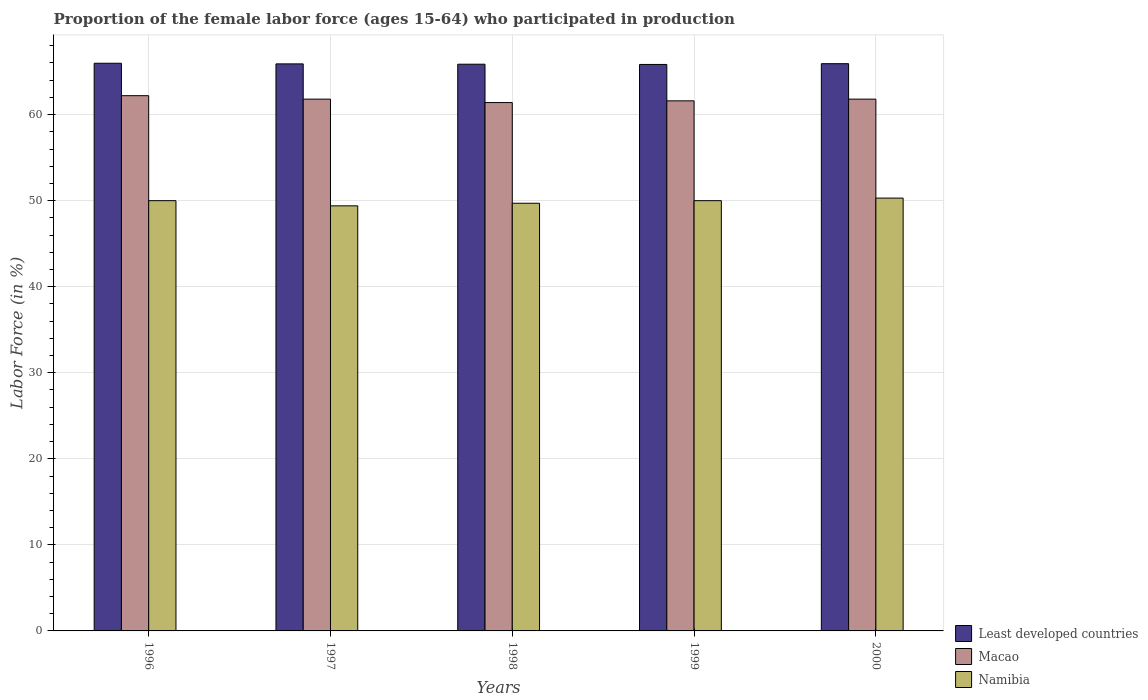Are the number of bars on each tick of the X-axis equal?
Your answer should be very brief. Yes. How many bars are there on the 4th tick from the right?
Make the answer very short. 3. What is the proportion of the female labor force who participated in production in Macao in 2000?
Keep it short and to the point. 61.8. Across all years, what is the maximum proportion of the female labor force who participated in production in Macao?
Provide a short and direct response. 62.2. Across all years, what is the minimum proportion of the female labor force who participated in production in Least developed countries?
Make the answer very short. 65.83. In which year was the proportion of the female labor force who participated in production in Macao maximum?
Offer a terse response. 1996. What is the total proportion of the female labor force who participated in production in Namibia in the graph?
Ensure brevity in your answer.  249.4. What is the difference between the proportion of the female labor force who participated in production in Namibia in 1996 and that in 1998?
Provide a short and direct response. 0.3. What is the difference between the proportion of the female labor force who participated in production in Least developed countries in 1997 and the proportion of the female labor force who participated in production in Macao in 1996?
Your answer should be compact. 3.7. What is the average proportion of the female labor force who participated in production in Macao per year?
Ensure brevity in your answer.  61.76. What is the ratio of the proportion of the female labor force who participated in production in Namibia in 1996 to that in 1999?
Provide a short and direct response. 1. What is the difference between the highest and the second highest proportion of the female labor force who participated in production in Least developed countries?
Provide a succinct answer. 0.05. What is the difference between the highest and the lowest proportion of the female labor force who participated in production in Namibia?
Your answer should be very brief. 0.9. In how many years, is the proportion of the female labor force who participated in production in Namibia greater than the average proportion of the female labor force who participated in production in Namibia taken over all years?
Provide a short and direct response. 3. What does the 3rd bar from the left in 1996 represents?
Offer a terse response. Namibia. What does the 2nd bar from the right in 2000 represents?
Provide a succinct answer. Macao. How many bars are there?
Provide a short and direct response. 15. Are the values on the major ticks of Y-axis written in scientific E-notation?
Ensure brevity in your answer.  No. Does the graph contain any zero values?
Offer a very short reply. No. How are the legend labels stacked?
Your answer should be compact. Vertical. What is the title of the graph?
Provide a succinct answer. Proportion of the female labor force (ages 15-64) who participated in production. Does "Montenegro" appear as one of the legend labels in the graph?
Give a very brief answer. No. What is the label or title of the Y-axis?
Make the answer very short. Labor Force (in %). What is the Labor Force (in %) in Least developed countries in 1996?
Ensure brevity in your answer.  65.97. What is the Labor Force (in %) in Macao in 1996?
Ensure brevity in your answer.  62.2. What is the Labor Force (in %) of Namibia in 1996?
Make the answer very short. 50. What is the Labor Force (in %) of Least developed countries in 1997?
Offer a very short reply. 65.9. What is the Labor Force (in %) in Macao in 1997?
Your answer should be compact. 61.8. What is the Labor Force (in %) in Namibia in 1997?
Ensure brevity in your answer.  49.4. What is the Labor Force (in %) in Least developed countries in 1998?
Give a very brief answer. 65.86. What is the Labor Force (in %) of Macao in 1998?
Ensure brevity in your answer.  61.4. What is the Labor Force (in %) of Namibia in 1998?
Ensure brevity in your answer.  49.7. What is the Labor Force (in %) in Least developed countries in 1999?
Your response must be concise. 65.83. What is the Labor Force (in %) of Macao in 1999?
Offer a very short reply. 61.6. What is the Labor Force (in %) in Least developed countries in 2000?
Offer a very short reply. 65.92. What is the Labor Force (in %) in Macao in 2000?
Make the answer very short. 61.8. What is the Labor Force (in %) in Namibia in 2000?
Give a very brief answer. 50.3. Across all years, what is the maximum Labor Force (in %) in Least developed countries?
Your response must be concise. 65.97. Across all years, what is the maximum Labor Force (in %) in Macao?
Offer a terse response. 62.2. Across all years, what is the maximum Labor Force (in %) of Namibia?
Your response must be concise. 50.3. Across all years, what is the minimum Labor Force (in %) of Least developed countries?
Offer a terse response. 65.83. Across all years, what is the minimum Labor Force (in %) in Macao?
Your response must be concise. 61.4. Across all years, what is the minimum Labor Force (in %) in Namibia?
Your answer should be very brief. 49.4. What is the total Labor Force (in %) in Least developed countries in the graph?
Ensure brevity in your answer.  329.47. What is the total Labor Force (in %) of Macao in the graph?
Your answer should be compact. 308.8. What is the total Labor Force (in %) in Namibia in the graph?
Keep it short and to the point. 249.4. What is the difference between the Labor Force (in %) in Least developed countries in 1996 and that in 1997?
Offer a terse response. 0.07. What is the difference between the Labor Force (in %) in Namibia in 1996 and that in 1997?
Your answer should be compact. 0.6. What is the difference between the Labor Force (in %) in Least developed countries in 1996 and that in 1998?
Your answer should be compact. 0.11. What is the difference between the Labor Force (in %) of Macao in 1996 and that in 1998?
Keep it short and to the point. 0.8. What is the difference between the Labor Force (in %) in Least developed countries in 1996 and that in 1999?
Make the answer very short. 0.14. What is the difference between the Labor Force (in %) of Namibia in 1996 and that in 1999?
Your response must be concise. 0. What is the difference between the Labor Force (in %) of Least developed countries in 1996 and that in 2000?
Make the answer very short. 0.05. What is the difference between the Labor Force (in %) of Namibia in 1996 and that in 2000?
Your answer should be compact. -0.3. What is the difference between the Labor Force (in %) in Least developed countries in 1997 and that in 1998?
Your answer should be compact. 0.04. What is the difference between the Labor Force (in %) of Least developed countries in 1997 and that in 1999?
Your answer should be very brief. 0.06. What is the difference between the Labor Force (in %) in Least developed countries in 1997 and that in 2000?
Offer a terse response. -0.02. What is the difference between the Labor Force (in %) in Least developed countries in 1998 and that in 1999?
Offer a very short reply. 0.03. What is the difference between the Labor Force (in %) of Namibia in 1998 and that in 1999?
Your answer should be compact. -0.3. What is the difference between the Labor Force (in %) in Least developed countries in 1998 and that in 2000?
Your answer should be very brief. -0.06. What is the difference between the Labor Force (in %) of Macao in 1998 and that in 2000?
Your response must be concise. -0.4. What is the difference between the Labor Force (in %) of Least developed countries in 1999 and that in 2000?
Ensure brevity in your answer.  -0.09. What is the difference between the Labor Force (in %) in Macao in 1999 and that in 2000?
Your answer should be very brief. -0.2. What is the difference between the Labor Force (in %) in Namibia in 1999 and that in 2000?
Provide a succinct answer. -0.3. What is the difference between the Labor Force (in %) of Least developed countries in 1996 and the Labor Force (in %) of Macao in 1997?
Your answer should be compact. 4.17. What is the difference between the Labor Force (in %) of Least developed countries in 1996 and the Labor Force (in %) of Namibia in 1997?
Your answer should be very brief. 16.57. What is the difference between the Labor Force (in %) in Macao in 1996 and the Labor Force (in %) in Namibia in 1997?
Ensure brevity in your answer.  12.8. What is the difference between the Labor Force (in %) in Least developed countries in 1996 and the Labor Force (in %) in Macao in 1998?
Ensure brevity in your answer.  4.57. What is the difference between the Labor Force (in %) of Least developed countries in 1996 and the Labor Force (in %) of Namibia in 1998?
Offer a very short reply. 16.27. What is the difference between the Labor Force (in %) in Macao in 1996 and the Labor Force (in %) in Namibia in 1998?
Keep it short and to the point. 12.5. What is the difference between the Labor Force (in %) in Least developed countries in 1996 and the Labor Force (in %) in Macao in 1999?
Offer a terse response. 4.37. What is the difference between the Labor Force (in %) of Least developed countries in 1996 and the Labor Force (in %) of Namibia in 1999?
Ensure brevity in your answer.  15.97. What is the difference between the Labor Force (in %) of Macao in 1996 and the Labor Force (in %) of Namibia in 1999?
Your response must be concise. 12.2. What is the difference between the Labor Force (in %) of Least developed countries in 1996 and the Labor Force (in %) of Macao in 2000?
Your answer should be compact. 4.17. What is the difference between the Labor Force (in %) in Least developed countries in 1996 and the Labor Force (in %) in Namibia in 2000?
Your response must be concise. 15.67. What is the difference between the Labor Force (in %) of Macao in 1996 and the Labor Force (in %) of Namibia in 2000?
Provide a succinct answer. 11.9. What is the difference between the Labor Force (in %) of Least developed countries in 1997 and the Labor Force (in %) of Macao in 1998?
Ensure brevity in your answer.  4.5. What is the difference between the Labor Force (in %) in Least developed countries in 1997 and the Labor Force (in %) in Namibia in 1998?
Provide a short and direct response. 16.2. What is the difference between the Labor Force (in %) of Macao in 1997 and the Labor Force (in %) of Namibia in 1998?
Provide a short and direct response. 12.1. What is the difference between the Labor Force (in %) in Least developed countries in 1997 and the Labor Force (in %) in Macao in 1999?
Ensure brevity in your answer.  4.3. What is the difference between the Labor Force (in %) in Least developed countries in 1997 and the Labor Force (in %) in Namibia in 1999?
Provide a succinct answer. 15.9. What is the difference between the Labor Force (in %) in Least developed countries in 1997 and the Labor Force (in %) in Macao in 2000?
Give a very brief answer. 4.1. What is the difference between the Labor Force (in %) of Least developed countries in 1997 and the Labor Force (in %) of Namibia in 2000?
Your answer should be very brief. 15.6. What is the difference between the Labor Force (in %) in Macao in 1997 and the Labor Force (in %) in Namibia in 2000?
Your response must be concise. 11.5. What is the difference between the Labor Force (in %) in Least developed countries in 1998 and the Labor Force (in %) in Macao in 1999?
Your response must be concise. 4.26. What is the difference between the Labor Force (in %) of Least developed countries in 1998 and the Labor Force (in %) of Namibia in 1999?
Keep it short and to the point. 15.86. What is the difference between the Labor Force (in %) in Macao in 1998 and the Labor Force (in %) in Namibia in 1999?
Your answer should be very brief. 11.4. What is the difference between the Labor Force (in %) of Least developed countries in 1998 and the Labor Force (in %) of Macao in 2000?
Offer a very short reply. 4.06. What is the difference between the Labor Force (in %) of Least developed countries in 1998 and the Labor Force (in %) of Namibia in 2000?
Your answer should be very brief. 15.56. What is the difference between the Labor Force (in %) of Macao in 1998 and the Labor Force (in %) of Namibia in 2000?
Provide a short and direct response. 11.1. What is the difference between the Labor Force (in %) in Least developed countries in 1999 and the Labor Force (in %) in Macao in 2000?
Your answer should be very brief. 4.03. What is the difference between the Labor Force (in %) in Least developed countries in 1999 and the Labor Force (in %) in Namibia in 2000?
Ensure brevity in your answer.  15.53. What is the average Labor Force (in %) in Least developed countries per year?
Your response must be concise. 65.89. What is the average Labor Force (in %) in Macao per year?
Provide a short and direct response. 61.76. What is the average Labor Force (in %) of Namibia per year?
Provide a short and direct response. 49.88. In the year 1996, what is the difference between the Labor Force (in %) in Least developed countries and Labor Force (in %) in Macao?
Your answer should be compact. 3.77. In the year 1996, what is the difference between the Labor Force (in %) of Least developed countries and Labor Force (in %) of Namibia?
Keep it short and to the point. 15.97. In the year 1997, what is the difference between the Labor Force (in %) in Least developed countries and Labor Force (in %) in Macao?
Provide a succinct answer. 4.1. In the year 1997, what is the difference between the Labor Force (in %) in Least developed countries and Labor Force (in %) in Namibia?
Your response must be concise. 16.5. In the year 1997, what is the difference between the Labor Force (in %) of Macao and Labor Force (in %) of Namibia?
Provide a short and direct response. 12.4. In the year 1998, what is the difference between the Labor Force (in %) in Least developed countries and Labor Force (in %) in Macao?
Your response must be concise. 4.46. In the year 1998, what is the difference between the Labor Force (in %) in Least developed countries and Labor Force (in %) in Namibia?
Offer a very short reply. 16.16. In the year 1999, what is the difference between the Labor Force (in %) in Least developed countries and Labor Force (in %) in Macao?
Your answer should be very brief. 4.23. In the year 1999, what is the difference between the Labor Force (in %) in Least developed countries and Labor Force (in %) in Namibia?
Offer a very short reply. 15.83. In the year 1999, what is the difference between the Labor Force (in %) of Macao and Labor Force (in %) of Namibia?
Make the answer very short. 11.6. In the year 2000, what is the difference between the Labor Force (in %) of Least developed countries and Labor Force (in %) of Macao?
Ensure brevity in your answer.  4.12. In the year 2000, what is the difference between the Labor Force (in %) of Least developed countries and Labor Force (in %) of Namibia?
Provide a short and direct response. 15.62. What is the ratio of the Labor Force (in %) of Least developed countries in 1996 to that in 1997?
Your answer should be very brief. 1. What is the ratio of the Labor Force (in %) of Macao in 1996 to that in 1997?
Your answer should be compact. 1.01. What is the ratio of the Labor Force (in %) in Namibia in 1996 to that in 1997?
Your answer should be very brief. 1.01. What is the ratio of the Labor Force (in %) of Least developed countries in 1996 to that in 1998?
Provide a succinct answer. 1. What is the ratio of the Labor Force (in %) in Macao in 1996 to that in 1998?
Keep it short and to the point. 1.01. What is the ratio of the Labor Force (in %) of Namibia in 1996 to that in 1998?
Offer a terse response. 1.01. What is the ratio of the Labor Force (in %) in Macao in 1996 to that in 1999?
Your response must be concise. 1.01. What is the ratio of the Labor Force (in %) in Macao in 1997 to that in 1998?
Make the answer very short. 1.01. What is the ratio of the Labor Force (in %) of Least developed countries in 1997 to that in 1999?
Ensure brevity in your answer.  1. What is the ratio of the Labor Force (in %) in Macao in 1997 to that in 1999?
Your response must be concise. 1. What is the ratio of the Labor Force (in %) in Least developed countries in 1997 to that in 2000?
Your response must be concise. 1. What is the ratio of the Labor Force (in %) of Macao in 1997 to that in 2000?
Give a very brief answer. 1. What is the ratio of the Labor Force (in %) in Namibia in 1997 to that in 2000?
Your response must be concise. 0.98. What is the ratio of the Labor Force (in %) of Least developed countries in 1998 to that in 1999?
Your response must be concise. 1. What is the ratio of the Labor Force (in %) in Macao in 1998 to that in 1999?
Keep it short and to the point. 1. What is the ratio of the Labor Force (in %) in Namibia in 1998 to that in 1999?
Make the answer very short. 0.99. What is the ratio of the Labor Force (in %) in Macao in 1998 to that in 2000?
Your answer should be very brief. 0.99. What is the ratio of the Labor Force (in %) of Namibia in 1998 to that in 2000?
Keep it short and to the point. 0.99. What is the ratio of the Labor Force (in %) of Least developed countries in 1999 to that in 2000?
Your response must be concise. 1. What is the difference between the highest and the second highest Labor Force (in %) in Least developed countries?
Your response must be concise. 0.05. What is the difference between the highest and the second highest Labor Force (in %) of Namibia?
Make the answer very short. 0.3. What is the difference between the highest and the lowest Labor Force (in %) in Least developed countries?
Provide a succinct answer. 0.14. 